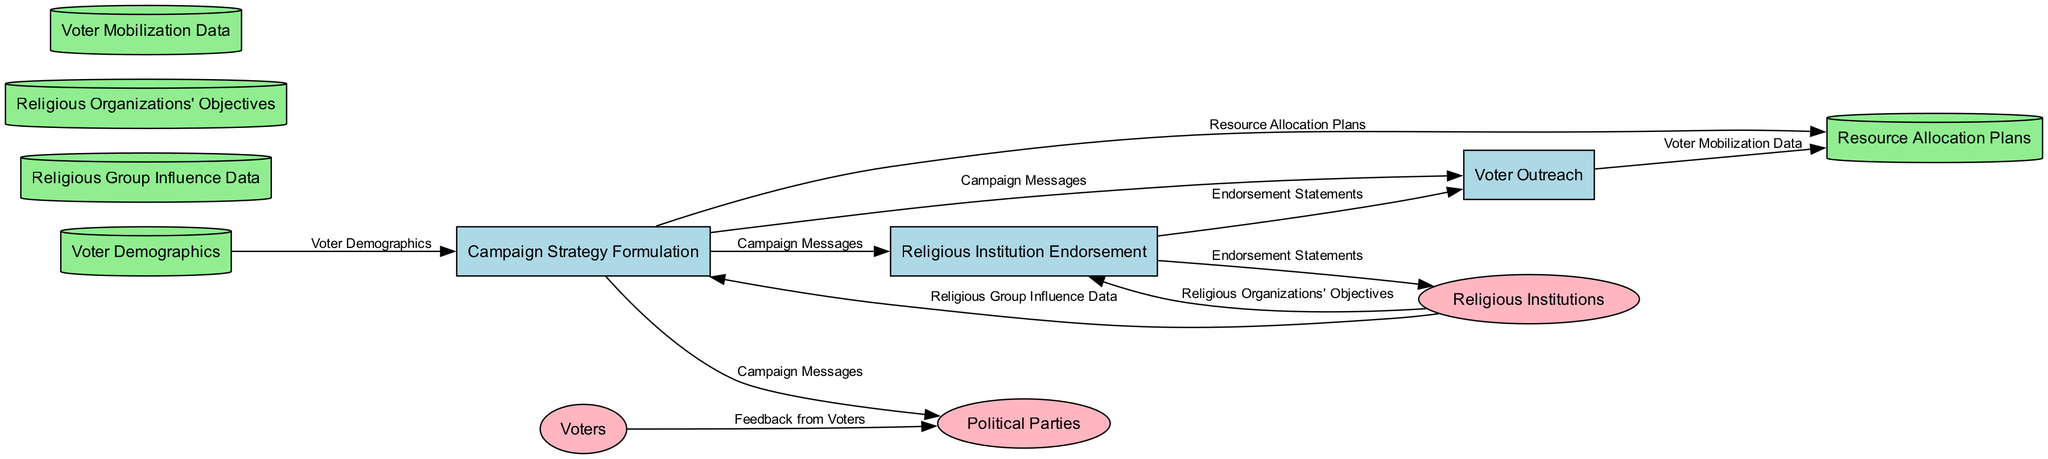What is the first process in the diagram? The first process listed in the "Processes" section is "Campaign Strategy Formulation."
Answer: Campaign Strategy Formulation How many data stores are present in the diagram? The diagram lists four distinct data stores: "Voter Demographics," "Religious Group Influence Data," "Religious Organizations' Objectives," and "Resource Allocation Plans."
Answer: 4 Which external entity provides feedback to political parties? The external entity that provides feedback to political parties is "Voters," as shown in the data flows.
Answer: Voters What type of data flows from "Religious Institution Endorsement" to "Voter Outreach"? The type of data that flows from "Religious Institution Endorsement" to "Voter Outreach" is "Endorsement Statements."
Answer: Endorsement Statements What relationship exists between "Campaign Strategy Formulation" and "Resource Allocation Plans"? "Campaign Strategy Formulation" outputs "Resource Allocation Plans," indicating a directional flow of information. This means that the process formulates plans used for resource management in campaigns.
Answer: Outputs How does "Religious Institutions" influence "Campaign Strategy Formulation"? "Religious Institutions" supply "Religious Group Influence Data" as input to "Campaign Strategy Formulation," which is crucial for shaping the campaign strategies.
Answer: Provides data What are the two outputs of the "Voter Outreach" process? The outputs of the "Voter Outreach" process are "Voter Mobilization Data" and "Feedback from Voters," indicating the end results from outreach efforts.
Answer: Voter Mobilization Data, Feedback from Voters Which input data flows into the process "Religious Institution Endorsement"? The inputs into the "Religious Institution Endorsement" process are "Campaign Messages" and "Religious Organizations' Objectives," necessary for achieving its functions.
Answer: Campaign Messages, Religious Organizations' Objectives What do "Campaign Messages" influence in the diagram? "Campaign Messages" influence multiple aspects: they are sent to "Political Parties," "Religious Institution Endorsement," and "Voter Outreach," demonstrating their role in shaping different campaign elements.
Answer: Political Parties, Religious Institution Endorsement, Voter Outreach 